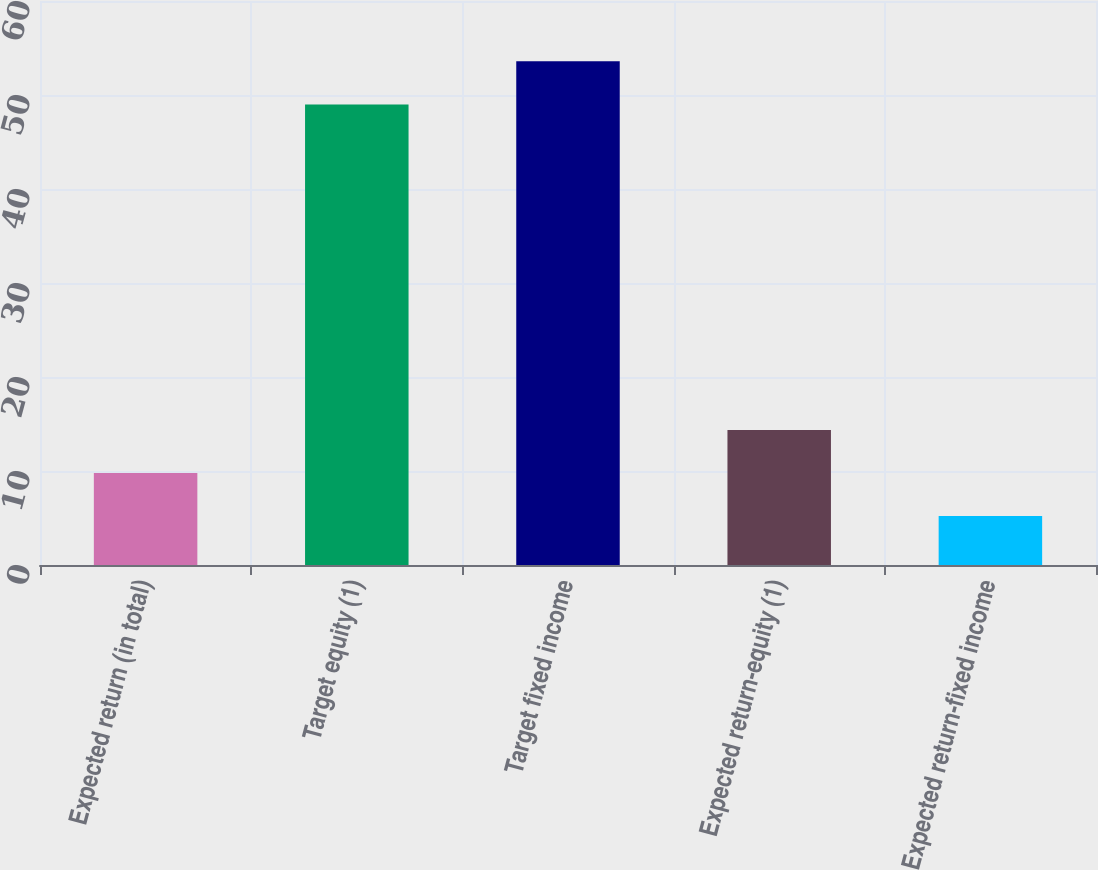Convert chart. <chart><loc_0><loc_0><loc_500><loc_500><bar_chart><fcel>Expected return (in total)<fcel>Target equity (1)<fcel>Target fixed income<fcel>Expected return-equity (1)<fcel>Expected return-fixed income<nl><fcel>9.78<fcel>49<fcel>53.58<fcel>14.36<fcel>5.2<nl></chart> 